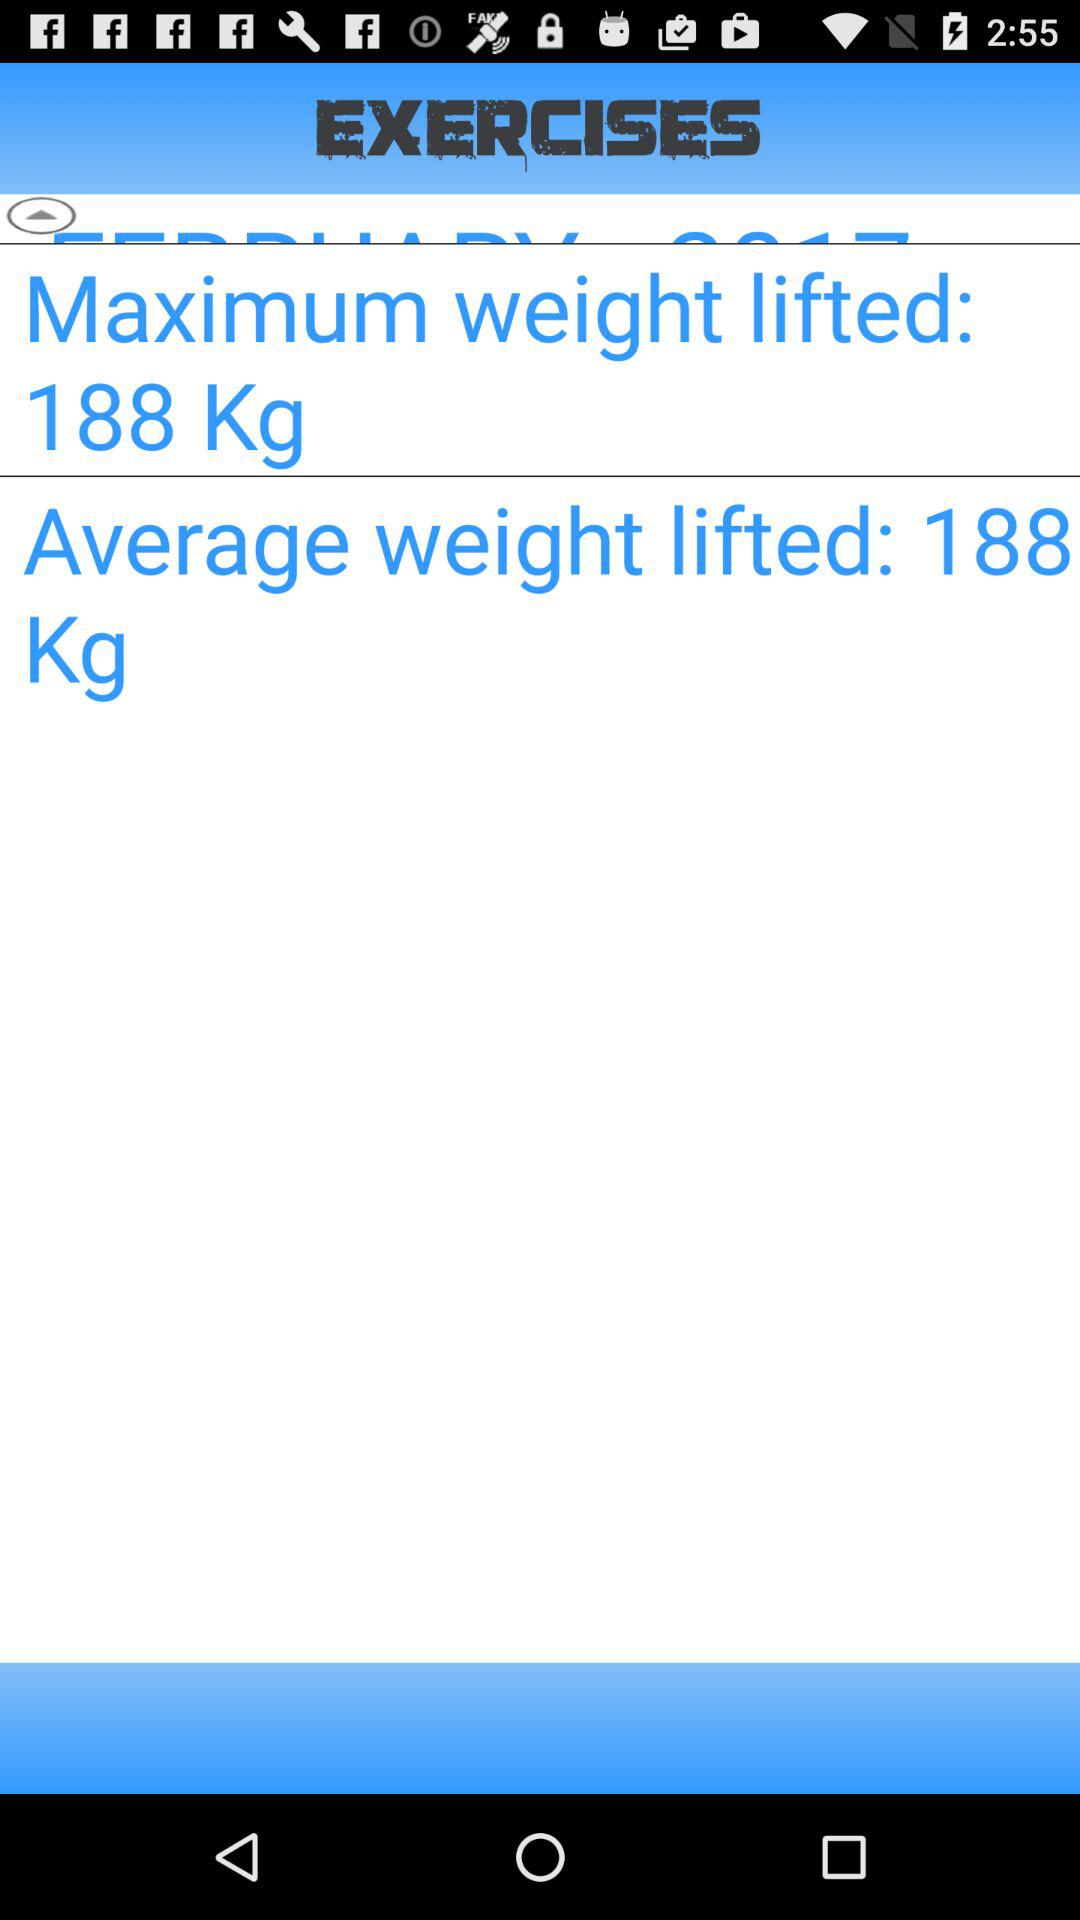What is the average weight lifted? The average weight lifted is 188 kg. 